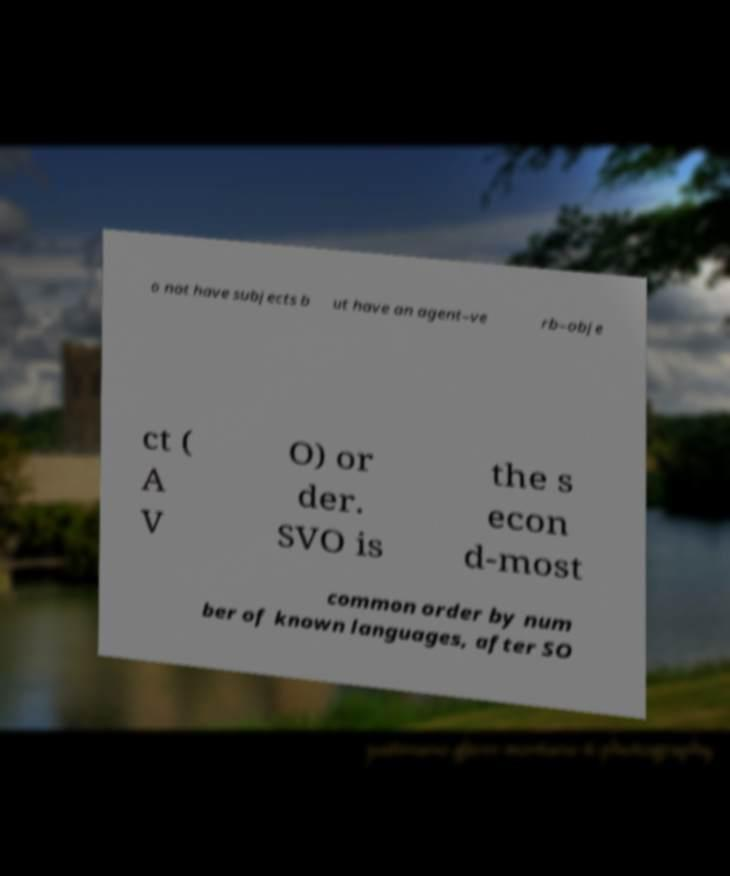Could you assist in decoding the text presented in this image and type it out clearly? o not have subjects b ut have an agent–ve rb–obje ct ( A V O) or der. SVO is the s econ d-most common order by num ber of known languages, after SO 